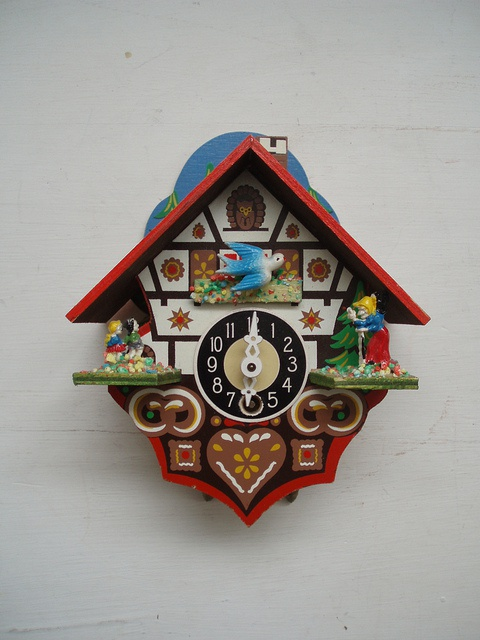Describe the objects in this image and their specific colors. I can see clock in darkgray, black, tan, and lightgray tones and bird in darkgray and teal tones in this image. 